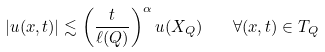Convert formula to latex. <formula><loc_0><loc_0><loc_500><loc_500>| u ( x , t ) | \lesssim \left ( \frac { t } { \ell ( Q ) } \right ) ^ { \alpha } u ( X _ { Q } ) \quad \forall ( x , t ) \in T _ { Q }</formula> 